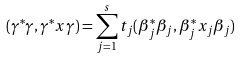<formula> <loc_0><loc_0><loc_500><loc_500>( \gamma ^ { * } \gamma , \gamma ^ { * } x \gamma ) = \sum _ { j = 1 } ^ { s } t _ { j } ( \beta _ { j } ^ { * } \beta _ { j } , \beta _ { j } ^ { * } x _ { j } \beta _ { j } )</formula> 